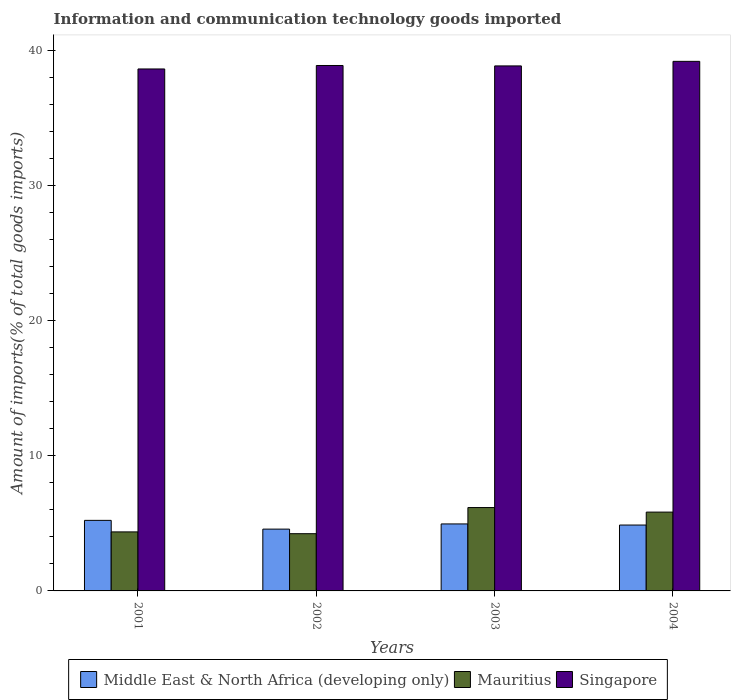How many groups of bars are there?
Your answer should be very brief. 4. Are the number of bars per tick equal to the number of legend labels?
Your answer should be very brief. Yes. What is the label of the 4th group of bars from the left?
Provide a succinct answer. 2004. What is the amount of goods imported in Middle East & North Africa (developing only) in 2004?
Make the answer very short. 4.88. Across all years, what is the maximum amount of goods imported in Singapore?
Your answer should be compact. 39.21. Across all years, what is the minimum amount of goods imported in Middle East & North Africa (developing only)?
Keep it short and to the point. 4.58. What is the total amount of goods imported in Singapore in the graph?
Offer a very short reply. 155.62. What is the difference between the amount of goods imported in Mauritius in 2002 and that in 2004?
Provide a succinct answer. -1.6. What is the difference between the amount of goods imported in Mauritius in 2001 and the amount of goods imported in Middle East & North Africa (developing only) in 2004?
Your response must be concise. -0.51. What is the average amount of goods imported in Middle East & North Africa (developing only) per year?
Provide a short and direct response. 4.91. In the year 2003, what is the difference between the amount of goods imported in Middle East & North Africa (developing only) and amount of goods imported in Mauritius?
Provide a succinct answer. -1.21. What is the ratio of the amount of goods imported in Singapore in 2001 to that in 2003?
Your answer should be compact. 0.99. Is the amount of goods imported in Middle East & North Africa (developing only) in 2002 less than that in 2004?
Offer a very short reply. Yes. Is the difference between the amount of goods imported in Middle East & North Africa (developing only) in 2001 and 2002 greater than the difference between the amount of goods imported in Mauritius in 2001 and 2002?
Ensure brevity in your answer.  Yes. What is the difference between the highest and the second highest amount of goods imported in Middle East & North Africa (developing only)?
Keep it short and to the point. 0.26. What is the difference between the highest and the lowest amount of goods imported in Mauritius?
Keep it short and to the point. 1.94. What does the 1st bar from the left in 2003 represents?
Your answer should be compact. Middle East & North Africa (developing only). What does the 2nd bar from the right in 2004 represents?
Offer a very short reply. Mauritius. Is it the case that in every year, the sum of the amount of goods imported in Singapore and amount of goods imported in Middle East & North Africa (developing only) is greater than the amount of goods imported in Mauritius?
Your answer should be compact. Yes. Are all the bars in the graph horizontal?
Your answer should be very brief. No. Where does the legend appear in the graph?
Keep it short and to the point. Bottom center. How are the legend labels stacked?
Ensure brevity in your answer.  Horizontal. What is the title of the graph?
Offer a terse response. Information and communication technology goods imported. Does "Chile" appear as one of the legend labels in the graph?
Your answer should be very brief. No. What is the label or title of the Y-axis?
Your response must be concise. Amount of imports(% of total goods imports). What is the Amount of imports(% of total goods imports) in Middle East & North Africa (developing only) in 2001?
Keep it short and to the point. 5.22. What is the Amount of imports(% of total goods imports) of Mauritius in 2001?
Make the answer very short. 4.37. What is the Amount of imports(% of total goods imports) in Singapore in 2001?
Provide a succinct answer. 38.64. What is the Amount of imports(% of total goods imports) of Middle East & North Africa (developing only) in 2002?
Ensure brevity in your answer.  4.58. What is the Amount of imports(% of total goods imports) of Mauritius in 2002?
Offer a very short reply. 4.24. What is the Amount of imports(% of total goods imports) in Singapore in 2002?
Your answer should be very brief. 38.9. What is the Amount of imports(% of total goods imports) in Middle East & North Africa (developing only) in 2003?
Provide a short and direct response. 4.96. What is the Amount of imports(% of total goods imports) in Mauritius in 2003?
Your answer should be very brief. 6.17. What is the Amount of imports(% of total goods imports) of Singapore in 2003?
Ensure brevity in your answer.  38.87. What is the Amount of imports(% of total goods imports) of Middle East & North Africa (developing only) in 2004?
Provide a succinct answer. 4.88. What is the Amount of imports(% of total goods imports) of Mauritius in 2004?
Make the answer very short. 5.84. What is the Amount of imports(% of total goods imports) in Singapore in 2004?
Keep it short and to the point. 39.21. Across all years, what is the maximum Amount of imports(% of total goods imports) in Middle East & North Africa (developing only)?
Make the answer very short. 5.22. Across all years, what is the maximum Amount of imports(% of total goods imports) in Mauritius?
Keep it short and to the point. 6.17. Across all years, what is the maximum Amount of imports(% of total goods imports) of Singapore?
Provide a succinct answer. 39.21. Across all years, what is the minimum Amount of imports(% of total goods imports) of Middle East & North Africa (developing only)?
Ensure brevity in your answer.  4.58. Across all years, what is the minimum Amount of imports(% of total goods imports) of Mauritius?
Your answer should be very brief. 4.24. Across all years, what is the minimum Amount of imports(% of total goods imports) of Singapore?
Make the answer very short. 38.64. What is the total Amount of imports(% of total goods imports) in Middle East & North Africa (developing only) in the graph?
Ensure brevity in your answer.  19.64. What is the total Amount of imports(% of total goods imports) in Mauritius in the graph?
Keep it short and to the point. 20.61. What is the total Amount of imports(% of total goods imports) of Singapore in the graph?
Your answer should be compact. 155.62. What is the difference between the Amount of imports(% of total goods imports) in Middle East & North Africa (developing only) in 2001 and that in 2002?
Make the answer very short. 0.65. What is the difference between the Amount of imports(% of total goods imports) in Mauritius in 2001 and that in 2002?
Provide a succinct answer. 0.13. What is the difference between the Amount of imports(% of total goods imports) in Singapore in 2001 and that in 2002?
Ensure brevity in your answer.  -0.26. What is the difference between the Amount of imports(% of total goods imports) in Middle East & North Africa (developing only) in 2001 and that in 2003?
Give a very brief answer. 0.26. What is the difference between the Amount of imports(% of total goods imports) in Mauritius in 2001 and that in 2003?
Provide a short and direct response. -1.8. What is the difference between the Amount of imports(% of total goods imports) in Singapore in 2001 and that in 2003?
Provide a succinct answer. -0.23. What is the difference between the Amount of imports(% of total goods imports) in Middle East & North Africa (developing only) in 2001 and that in 2004?
Keep it short and to the point. 0.35. What is the difference between the Amount of imports(% of total goods imports) in Mauritius in 2001 and that in 2004?
Keep it short and to the point. -1.46. What is the difference between the Amount of imports(% of total goods imports) of Singapore in 2001 and that in 2004?
Your answer should be compact. -0.56. What is the difference between the Amount of imports(% of total goods imports) of Middle East & North Africa (developing only) in 2002 and that in 2003?
Offer a terse response. -0.38. What is the difference between the Amount of imports(% of total goods imports) in Mauritius in 2002 and that in 2003?
Make the answer very short. -1.94. What is the difference between the Amount of imports(% of total goods imports) in Singapore in 2002 and that in 2003?
Offer a very short reply. 0.03. What is the difference between the Amount of imports(% of total goods imports) in Middle East & North Africa (developing only) in 2002 and that in 2004?
Your answer should be compact. -0.3. What is the difference between the Amount of imports(% of total goods imports) of Mauritius in 2002 and that in 2004?
Provide a short and direct response. -1.6. What is the difference between the Amount of imports(% of total goods imports) of Singapore in 2002 and that in 2004?
Provide a succinct answer. -0.31. What is the difference between the Amount of imports(% of total goods imports) of Middle East & North Africa (developing only) in 2003 and that in 2004?
Make the answer very short. 0.08. What is the difference between the Amount of imports(% of total goods imports) of Mauritius in 2003 and that in 2004?
Ensure brevity in your answer.  0.34. What is the difference between the Amount of imports(% of total goods imports) in Singapore in 2003 and that in 2004?
Give a very brief answer. -0.34. What is the difference between the Amount of imports(% of total goods imports) in Middle East & North Africa (developing only) in 2001 and the Amount of imports(% of total goods imports) in Mauritius in 2002?
Your answer should be compact. 0.99. What is the difference between the Amount of imports(% of total goods imports) in Middle East & North Africa (developing only) in 2001 and the Amount of imports(% of total goods imports) in Singapore in 2002?
Your answer should be compact. -33.68. What is the difference between the Amount of imports(% of total goods imports) in Mauritius in 2001 and the Amount of imports(% of total goods imports) in Singapore in 2002?
Your answer should be compact. -34.53. What is the difference between the Amount of imports(% of total goods imports) in Middle East & North Africa (developing only) in 2001 and the Amount of imports(% of total goods imports) in Mauritius in 2003?
Ensure brevity in your answer.  -0.95. What is the difference between the Amount of imports(% of total goods imports) in Middle East & North Africa (developing only) in 2001 and the Amount of imports(% of total goods imports) in Singapore in 2003?
Your answer should be compact. -33.65. What is the difference between the Amount of imports(% of total goods imports) of Mauritius in 2001 and the Amount of imports(% of total goods imports) of Singapore in 2003?
Offer a very short reply. -34.5. What is the difference between the Amount of imports(% of total goods imports) in Middle East & North Africa (developing only) in 2001 and the Amount of imports(% of total goods imports) in Mauritius in 2004?
Keep it short and to the point. -0.61. What is the difference between the Amount of imports(% of total goods imports) of Middle East & North Africa (developing only) in 2001 and the Amount of imports(% of total goods imports) of Singapore in 2004?
Offer a terse response. -33.98. What is the difference between the Amount of imports(% of total goods imports) in Mauritius in 2001 and the Amount of imports(% of total goods imports) in Singapore in 2004?
Your answer should be compact. -34.84. What is the difference between the Amount of imports(% of total goods imports) of Middle East & North Africa (developing only) in 2002 and the Amount of imports(% of total goods imports) of Mauritius in 2003?
Give a very brief answer. -1.6. What is the difference between the Amount of imports(% of total goods imports) in Middle East & North Africa (developing only) in 2002 and the Amount of imports(% of total goods imports) in Singapore in 2003?
Offer a very short reply. -34.29. What is the difference between the Amount of imports(% of total goods imports) in Mauritius in 2002 and the Amount of imports(% of total goods imports) in Singapore in 2003?
Provide a short and direct response. -34.63. What is the difference between the Amount of imports(% of total goods imports) of Middle East & North Africa (developing only) in 2002 and the Amount of imports(% of total goods imports) of Mauritius in 2004?
Keep it short and to the point. -1.26. What is the difference between the Amount of imports(% of total goods imports) in Middle East & North Africa (developing only) in 2002 and the Amount of imports(% of total goods imports) in Singapore in 2004?
Provide a short and direct response. -34.63. What is the difference between the Amount of imports(% of total goods imports) of Mauritius in 2002 and the Amount of imports(% of total goods imports) of Singapore in 2004?
Your answer should be very brief. -34.97. What is the difference between the Amount of imports(% of total goods imports) in Middle East & North Africa (developing only) in 2003 and the Amount of imports(% of total goods imports) in Mauritius in 2004?
Your response must be concise. -0.88. What is the difference between the Amount of imports(% of total goods imports) of Middle East & North Africa (developing only) in 2003 and the Amount of imports(% of total goods imports) of Singapore in 2004?
Give a very brief answer. -34.25. What is the difference between the Amount of imports(% of total goods imports) in Mauritius in 2003 and the Amount of imports(% of total goods imports) in Singapore in 2004?
Your answer should be very brief. -33.04. What is the average Amount of imports(% of total goods imports) of Middle East & North Africa (developing only) per year?
Your answer should be compact. 4.91. What is the average Amount of imports(% of total goods imports) of Mauritius per year?
Offer a very short reply. 5.15. What is the average Amount of imports(% of total goods imports) of Singapore per year?
Make the answer very short. 38.91. In the year 2001, what is the difference between the Amount of imports(% of total goods imports) of Middle East & North Africa (developing only) and Amount of imports(% of total goods imports) of Mauritius?
Provide a short and direct response. 0.85. In the year 2001, what is the difference between the Amount of imports(% of total goods imports) of Middle East & North Africa (developing only) and Amount of imports(% of total goods imports) of Singapore?
Ensure brevity in your answer.  -33.42. In the year 2001, what is the difference between the Amount of imports(% of total goods imports) in Mauritius and Amount of imports(% of total goods imports) in Singapore?
Provide a short and direct response. -34.27. In the year 2002, what is the difference between the Amount of imports(% of total goods imports) in Middle East & North Africa (developing only) and Amount of imports(% of total goods imports) in Mauritius?
Give a very brief answer. 0.34. In the year 2002, what is the difference between the Amount of imports(% of total goods imports) in Middle East & North Africa (developing only) and Amount of imports(% of total goods imports) in Singapore?
Ensure brevity in your answer.  -34.33. In the year 2002, what is the difference between the Amount of imports(% of total goods imports) in Mauritius and Amount of imports(% of total goods imports) in Singapore?
Provide a succinct answer. -34.66. In the year 2003, what is the difference between the Amount of imports(% of total goods imports) in Middle East & North Africa (developing only) and Amount of imports(% of total goods imports) in Mauritius?
Your answer should be compact. -1.21. In the year 2003, what is the difference between the Amount of imports(% of total goods imports) of Middle East & North Africa (developing only) and Amount of imports(% of total goods imports) of Singapore?
Offer a terse response. -33.91. In the year 2003, what is the difference between the Amount of imports(% of total goods imports) in Mauritius and Amount of imports(% of total goods imports) in Singapore?
Your answer should be compact. -32.7. In the year 2004, what is the difference between the Amount of imports(% of total goods imports) in Middle East & North Africa (developing only) and Amount of imports(% of total goods imports) in Mauritius?
Make the answer very short. -0.96. In the year 2004, what is the difference between the Amount of imports(% of total goods imports) in Middle East & North Africa (developing only) and Amount of imports(% of total goods imports) in Singapore?
Give a very brief answer. -34.33. In the year 2004, what is the difference between the Amount of imports(% of total goods imports) in Mauritius and Amount of imports(% of total goods imports) in Singapore?
Your response must be concise. -33.37. What is the ratio of the Amount of imports(% of total goods imports) in Middle East & North Africa (developing only) in 2001 to that in 2002?
Provide a succinct answer. 1.14. What is the ratio of the Amount of imports(% of total goods imports) in Mauritius in 2001 to that in 2002?
Give a very brief answer. 1.03. What is the ratio of the Amount of imports(% of total goods imports) of Middle East & North Africa (developing only) in 2001 to that in 2003?
Keep it short and to the point. 1.05. What is the ratio of the Amount of imports(% of total goods imports) of Mauritius in 2001 to that in 2003?
Your response must be concise. 0.71. What is the ratio of the Amount of imports(% of total goods imports) of Singapore in 2001 to that in 2003?
Give a very brief answer. 0.99. What is the ratio of the Amount of imports(% of total goods imports) in Middle East & North Africa (developing only) in 2001 to that in 2004?
Provide a succinct answer. 1.07. What is the ratio of the Amount of imports(% of total goods imports) in Mauritius in 2001 to that in 2004?
Keep it short and to the point. 0.75. What is the ratio of the Amount of imports(% of total goods imports) of Singapore in 2001 to that in 2004?
Your response must be concise. 0.99. What is the ratio of the Amount of imports(% of total goods imports) of Middle East & North Africa (developing only) in 2002 to that in 2003?
Give a very brief answer. 0.92. What is the ratio of the Amount of imports(% of total goods imports) in Mauritius in 2002 to that in 2003?
Offer a very short reply. 0.69. What is the ratio of the Amount of imports(% of total goods imports) in Middle East & North Africa (developing only) in 2002 to that in 2004?
Offer a very short reply. 0.94. What is the ratio of the Amount of imports(% of total goods imports) in Mauritius in 2002 to that in 2004?
Give a very brief answer. 0.73. What is the ratio of the Amount of imports(% of total goods imports) of Middle East & North Africa (developing only) in 2003 to that in 2004?
Offer a terse response. 1.02. What is the ratio of the Amount of imports(% of total goods imports) in Mauritius in 2003 to that in 2004?
Your answer should be compact. 1.06. What is the difference between the highest and the second highest Amount of imports(% of total goods imports) in Middle East & North Africa (developing only)?
Offer a terse response. 0.26. What is the difference between the highest and the second highest Amount of imports(% of total goods imports) of Mauritius?
Give a very brief answer. 0.34. What is the difference between the highest and the second highest Amount of imports(% of total goods imports) in Singapore?
Give a very brief answer. 0.31. What is the difference between the highest and the lowest Amount of imports(% of total goods imports) of Middle East & North Africa (developing only)?
Your answer should be very brief. 0.65. What is the difference between the highest and the lowest Amount of imports(% of total goods imports) in Mauritius?
Offer a very short reply. 1.94. What is the difference between the highest and the lowest Amount of imports(% of total goods imports) in Singapore?
Ensure brevity in your answer.  0.56. 